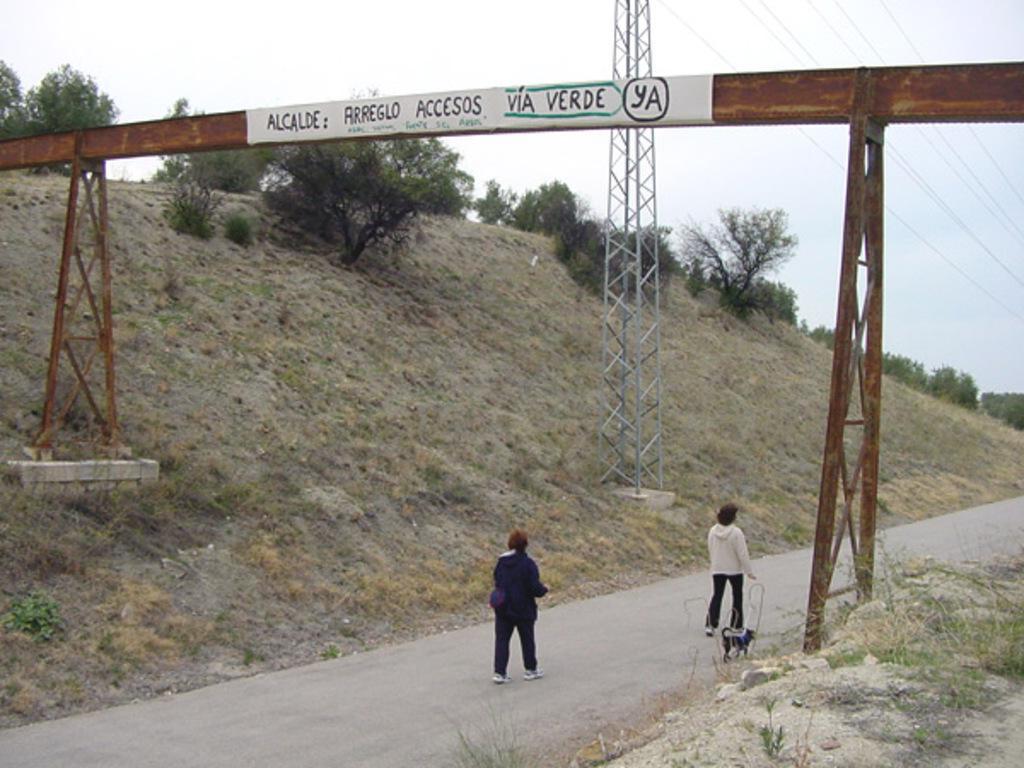Describe this image in one or two sentences. In this picture there are two women who are walking on the road. Beside them I can see the dog. In the center I can see the electric pole and wires are connected to it. On the mountain I can see many trees. On the right and left side I can see the steel pillars. At the top I can see the sky. 